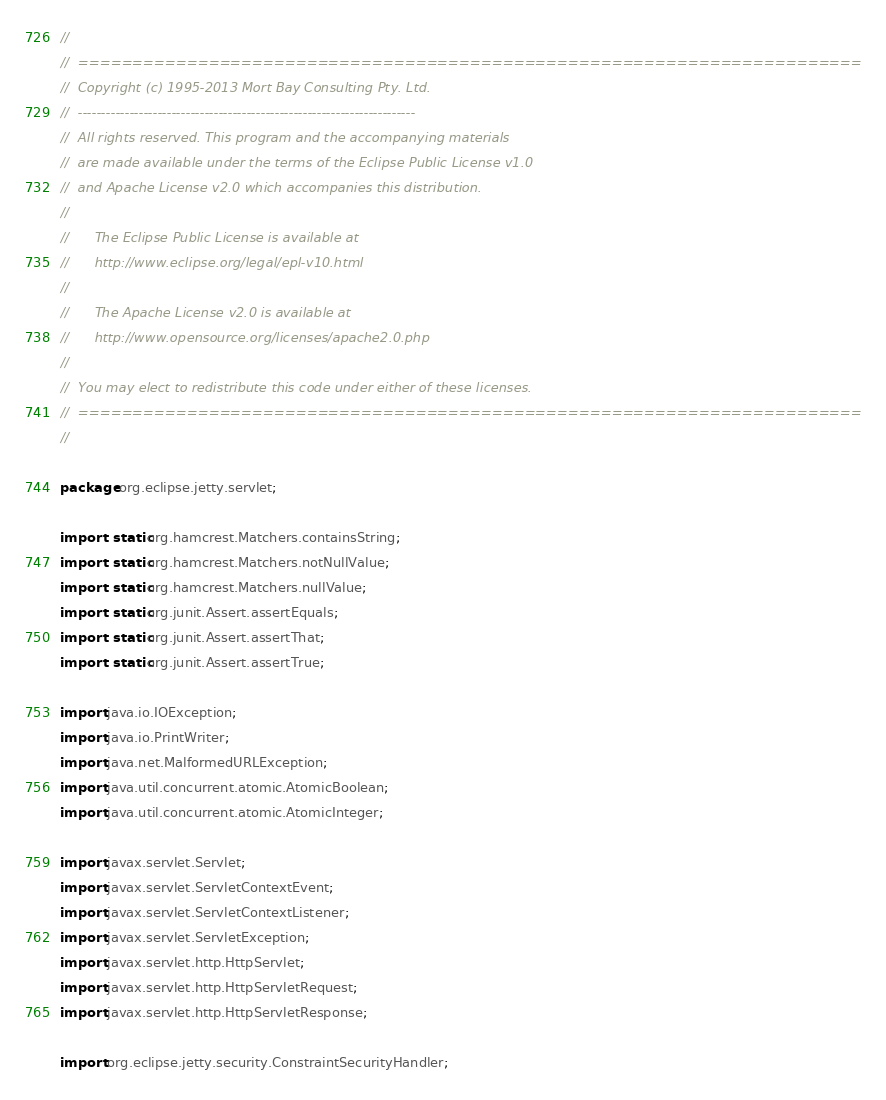Convert code to text. <code><loc_0><loc_0><loc_500><loc_500><_Java_>//
//  ========================================================================
//  Copyright (c) 1995-2013 Mort Bay Consulting Pty. Ltd.
//  ------------------------------------------------------------------------
//  All rights reserved. This program and the accompanying materials
//  are made available under the terms of the Eclipse Public License v1.0
//  and Apache License v2.0 which accompanies this distribution.
//
//      The Eclipse Public License is available at
//      http://www.eclipse.org/legal/epl-v10.html
//
//      The Apache License v2.0 is available at
//      http://www.opensource.org/licenses/apache2.0.php
//
//  You may elect to redistribute this code under either of these licenses.
//  ========================================================================
//

package org.eclipse.jetty.servlet;

import static org.hamcrest.Matchers.containsString;
import static org.hamcrest.Matchers.notNullValue;
import static org.hamcrest.Matchers.nullValue;
import static org.junit.Assert.assertEquals;
import static org.junit.Assert.assertThat;
import static org.junit.Assert.assertTrue;

import java.io.IOException;
import java.io.PrintWriter;
import java.net.MalformedURLException;
import java.util.concurrent.atomic.AtomicBoolean;
import java.util.concurrent.atomic.AtomicInteger;

import javax.servlet.Servlet;
import javax.servlet.ServletContextEvent;
import javax.servlet.ServletContextListener;
import javax.servlet.ServletException;
import javax.servlet.http.HttpServlet;
import javax.servlet.http.HttpServletRequest;
import javax.servlet.http.HttpServletResponse;

import org.eclipse.jetty.security.ConstraintSecurityHandler;</code> 